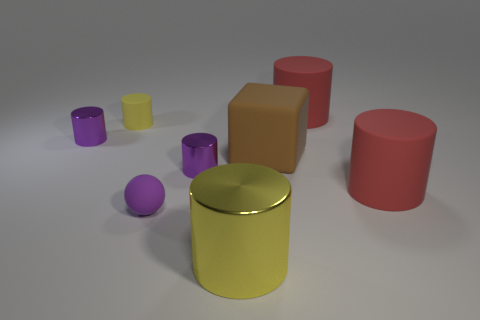Which object appears to be the tallest? The tallest object in the image seems to be the red cylinder. 